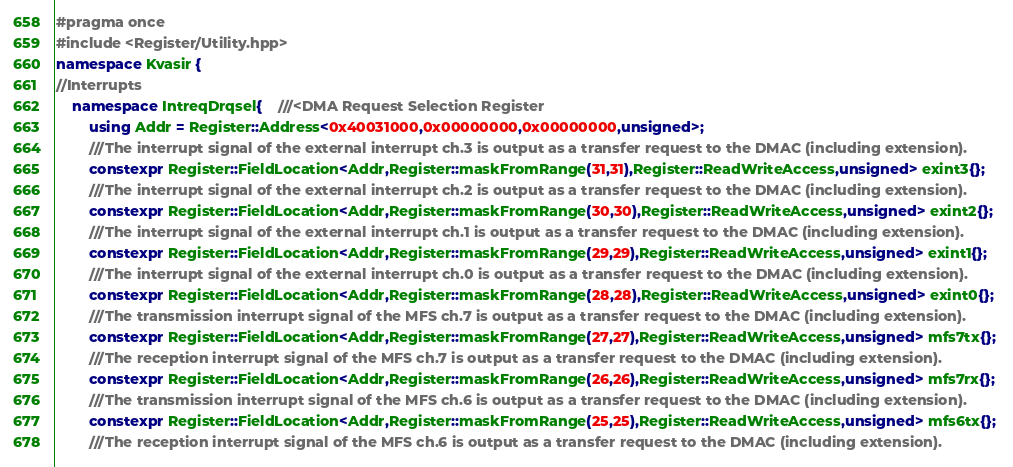Convert code to text. <code><loc_0><loc_0><loc_500><loc_500><_C++_>#pragma once 
#include <Register/Utility.hpp>
namespace Kvasir {
//Interrupts
    namespace IntreqDrqsel{    ///<DMA Request Selection Register
        using Addr = Register::Address<0x40031000,0x00000000,0x00000000,unsigned>;
        ///The interrupt signal of the external interrupt ch.3 is output as a transfer request to the DMAC (including extension).
        constexpr Register::FieldLocation<Addr,Register::maskFromRange(31,31),Register::ReadWriteAccess,unsigned> exint3{}; 
        ///The interrupt signal of the external interrupt ch.2 is output as a transfer request to the DMAC (including extension).
        constexpr Register::FieldLocation<Addr,Register::maskFromRange(30,30),Register::ReadWriteAccess,unsigned> exint2{}; 
        ///The interrupt signal of the external interrupt ch.1 is output as a transfer request to the DMAC (including extension).
        constexpr Register::FieldLocation<Addr,Register::maskFromRange(29,29),Register::ReadWriteAccess,unsigned> exint1{}; 
        ///The interrupt signal of the external interrupt ch.0 is output as a transfer request to the DMAC (including extension).
        constexpr Register::FieldLocation<Addr,Register::maskFromRange(28,28),Register::ReadWriteAccess,unsigned> exint0{}; 
        ///The transmission interrupt signal of the MFS ch.7 is output as a transfer request to the DMAC (including extension).
        constexpr Register::FieldLocation<Addr,Register::maskFromRange(27,27),Register::ReadWriteAccess,unsigned> mfs7tx{}; 
        ///The reception interrupt signal of the MFS ch.7 is output as a transfer request to the DMAC (including extension).
        constexpr Register::FieldLocation<Addr,Register::maskFromRange(26,26),Register::ReadWriteAccess,unsigned> mfs7rx{}; 
        ///The transmission interrupt signal of the MFS ch.6 is output as a transfer request to the DMAC (including extension).
        constexpr Register::FieldLocation<Addr,Register::maskFromRange(25,25),Register::ReadWriteAccess,unsigned> mfs6tx{}; 
        ///The reception interrupt signal of the MFS ch.6 is output as a transfer request to the DMAC (including extension).</code> 